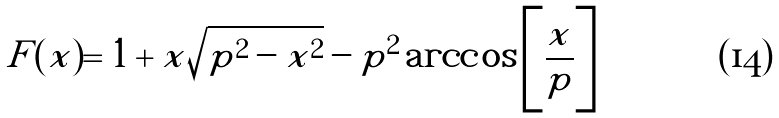Convert formula to latex. <formula><loc_0><loc_0><loc_500><loc_500>F ( x ) = 1 + x \sqrt { p ^ { 2 } - x ^ { 2 } } - p ^ { 2 } \arccos \left [ \frac { x } { p } \right ]</formula> 